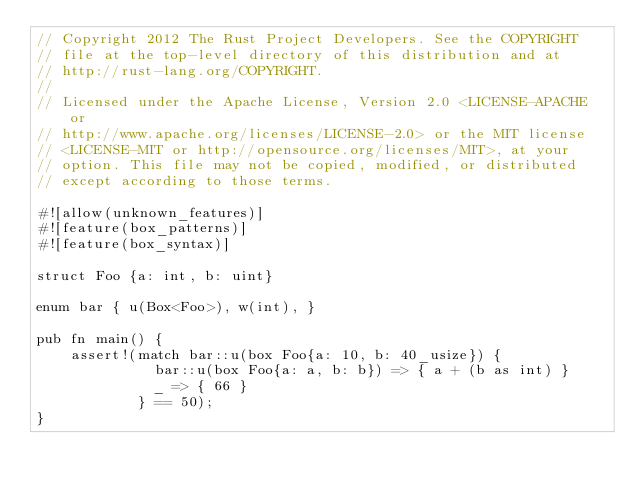Convert code to text. <code><loc_0><loc_0><loc_500><loc_500><_Rust_>// Copyright 2012 The Rust Project Developers. See the COPYRIGHT
// file at the top-level directory of this distribution and at
// http://rust-lang.org/COPYRIGHT.
//
// Licensed under the Apache License, Version 2.0 <LICENSE-APACHE or
// http://www.apache.org/licenses/LICENSE-2.0> or the MIT license
// <LICENSE-MIT or http://opensource.org/licenses/MIT>, at your
// option. This file may not be copied, modified, or distributed
// except according to those terms.

#![allow(unknown_features)]
#![feature(box_patterns)]
#![feature(box_syntax)]

struct Foo {a: int, b: uint}

enum bar { u(Box<Foo>), w(int), }

pub fn main() {
    assert!(match bar::u(box Foo{a: 10, b: 40_usize}) {
              bar::u(box Foo{a: a, b: b}) => { a + (b as int) }
              _ => { 66 }
            } == 50);
}
</code> 